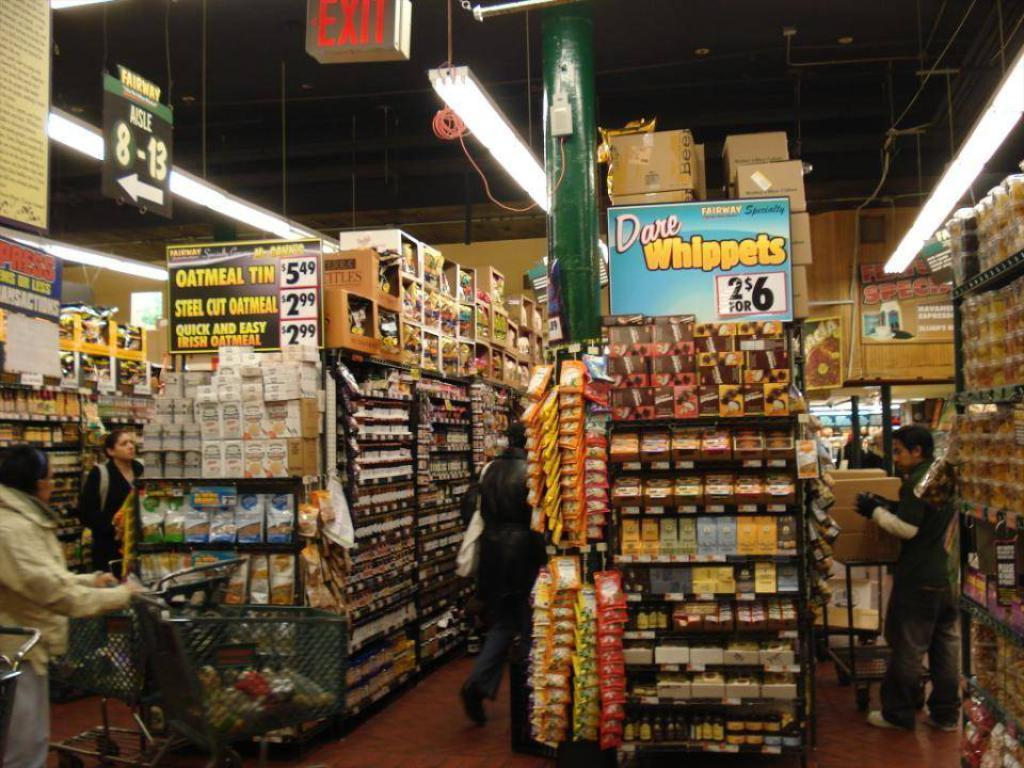<image>
Share a concise interpretation of the image provided. A grocery store advertising Dare Whippets in front of one of their aisles. 